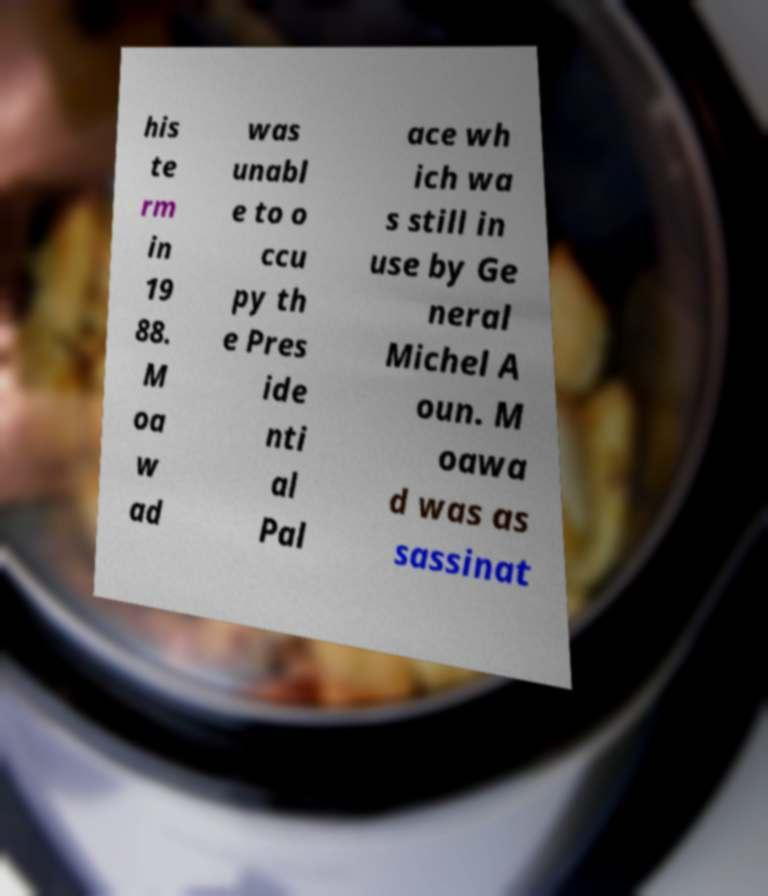I need the written content from this picture converted into text. Can you do that? his te rm in 19 88. M oa w ad was unabl e to o ccu py th e Pres ide nti al Pal ace wh ich wa s still in use by Ge neral Michel A oun. M oawa d was as sassinat 